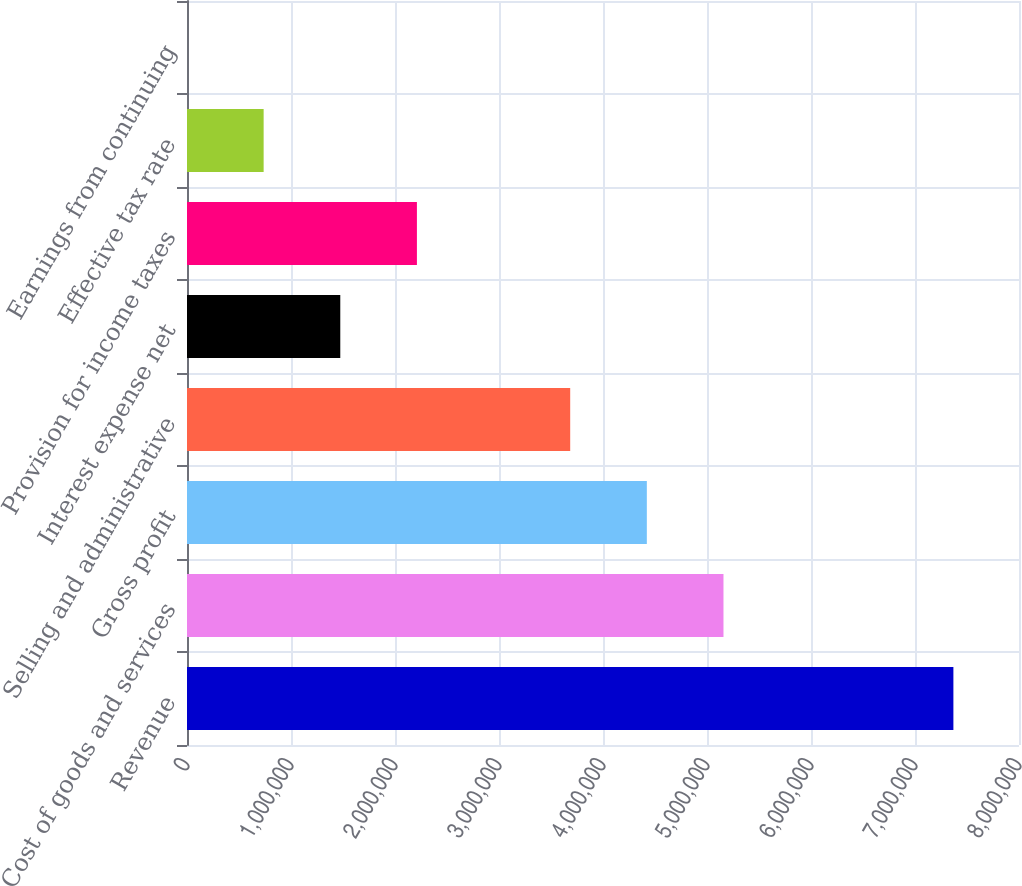<chart> <loc_0><loc_0><loc_500><loc_500><bar_chart><fcel>Revenue<fcel>Cost of goods and services<fcel>Gross profit<fcel>Selling and administrative<fcel>Interest expense net<fcel>Provision for income taxes<fcel>Effective tax rate<fcel>Earnings from continuing<nl><fcel>7.36915e+06<fcel>5.15841e+06<fcel>4.42149e+06<fcel>3.68458e+06<fcel>1.47383e+06<fcel>2.21075e+06<fcel>736919<fcel>4.09<nl></chart> 